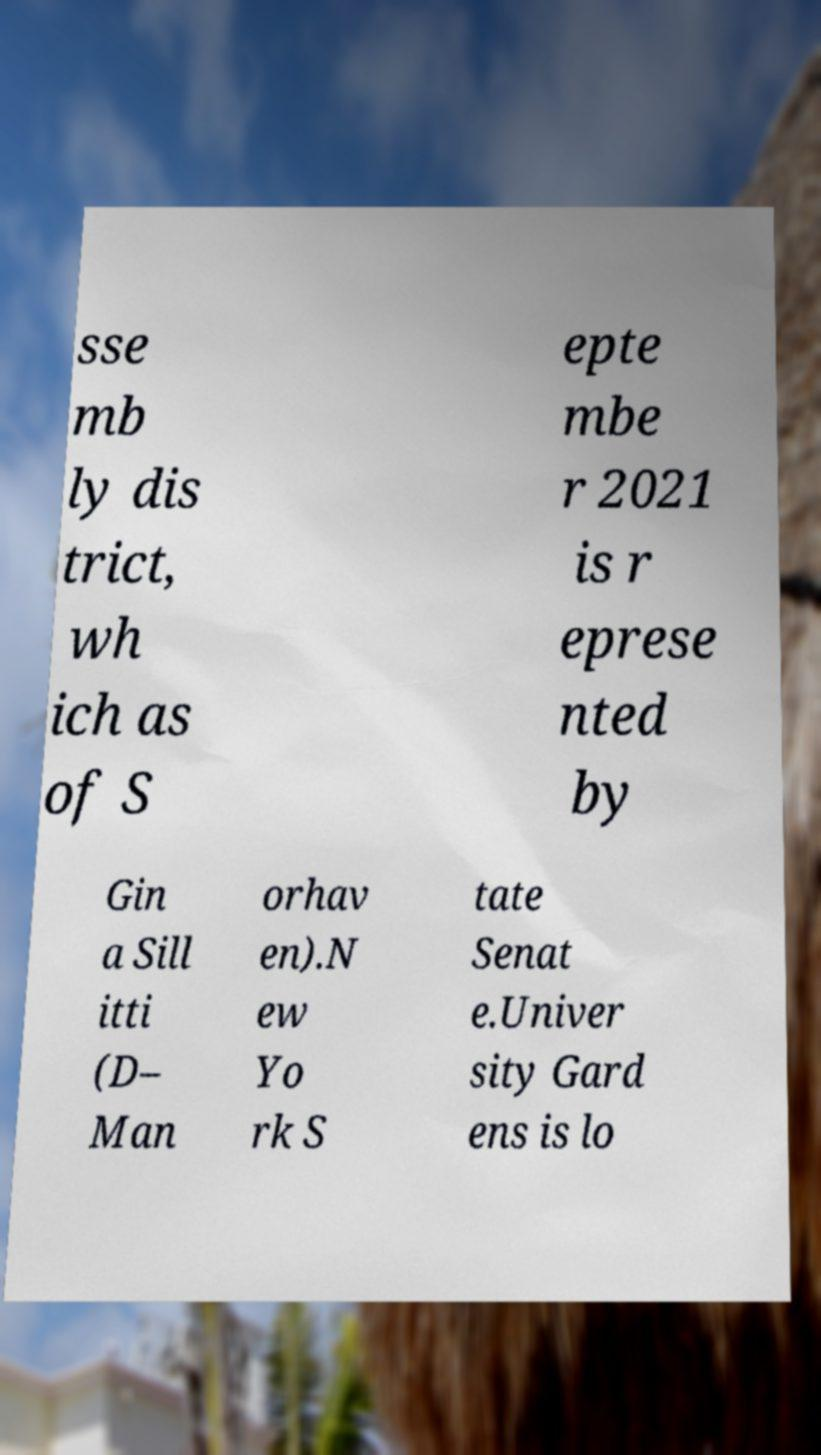Can you accurately transcribe the text from the provided image for me? sse mb ly dis trict, wh ich as of S epte mbe r 2021 is r eprese nted by Gin a Sill itti (D– Man orhav en).N ew Yo rk S tate Senat e.Univer sity Gard ens is lo 